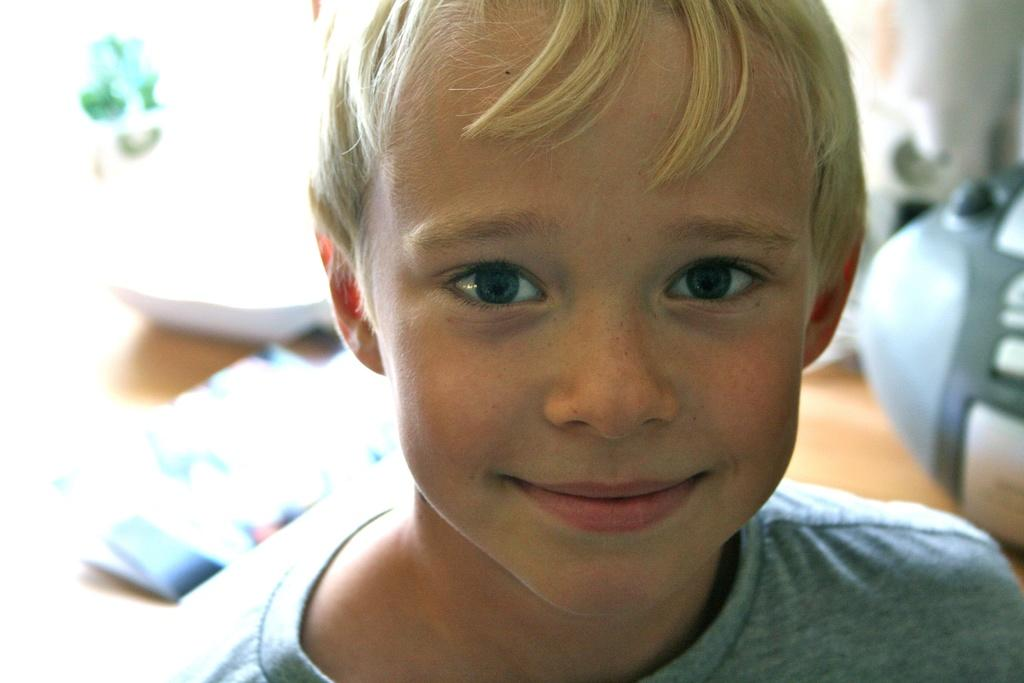What is the main subject in the foreground of the picture? There is a boy in the foreground of the picture. What is the boy's expression in the image? The boy is smiling in the image. Can you describe the background of the picture? The background of the image is not clear, so it is difficult to provide specific details. What type of pen is the boy holding in the image? There is no pen visible in the image; the boy is not holding any object. What form is the boy filling out in the image? There is no form present in the image; the boy is simply smiling in the foreground. 